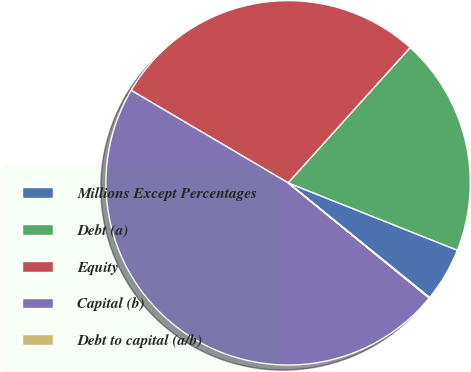Convert chart. <chart><loc_0><loc_0><loc_500><loc_500><pie_chart><fcel>Millions Except Percentages<fcel>Debt (a)<fcel>Equity<fcel>Capital (b)<fcel>Debt to capital (a/b)<nl><fcel>4.81%<fcel>19.35%<fcel>28.21%<fcel>47.57%<fcel>0.06%<nl></chart> 